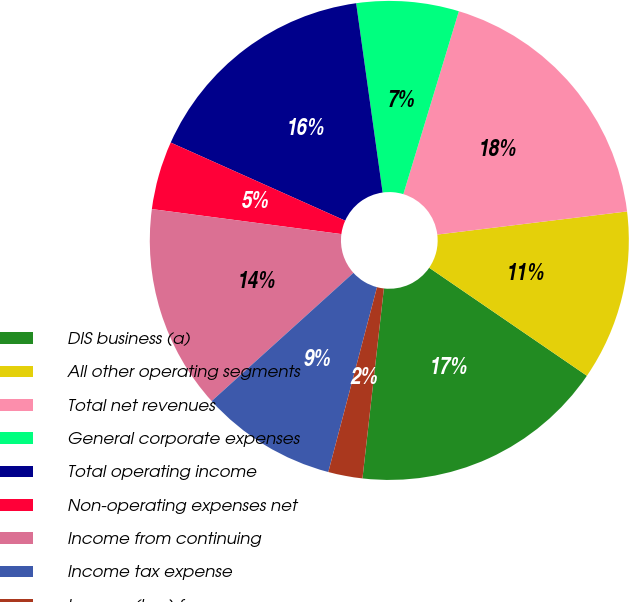Convert chart. <chart><loc_0><loc_0><loc_500><loc_500><pie_chart><fcel>DIS business (a)<fcel>All other operating segments<fcel>Total net revenues<fcel>General corporate expenses<fcel>Total operating income<fcel>Non-operating expenses net<fcel>Income from continuing<fcel>Income tax expense<fcel>Income (loss) from<nl><fcel>17.23%<fcel>11.49%<fcel>18.38%<fcel>6.9%<fcel>16.09%<fcel>4.61%<fcel>13.79%<fcel>9.2%<fcel>2.31%<nl></chart> 